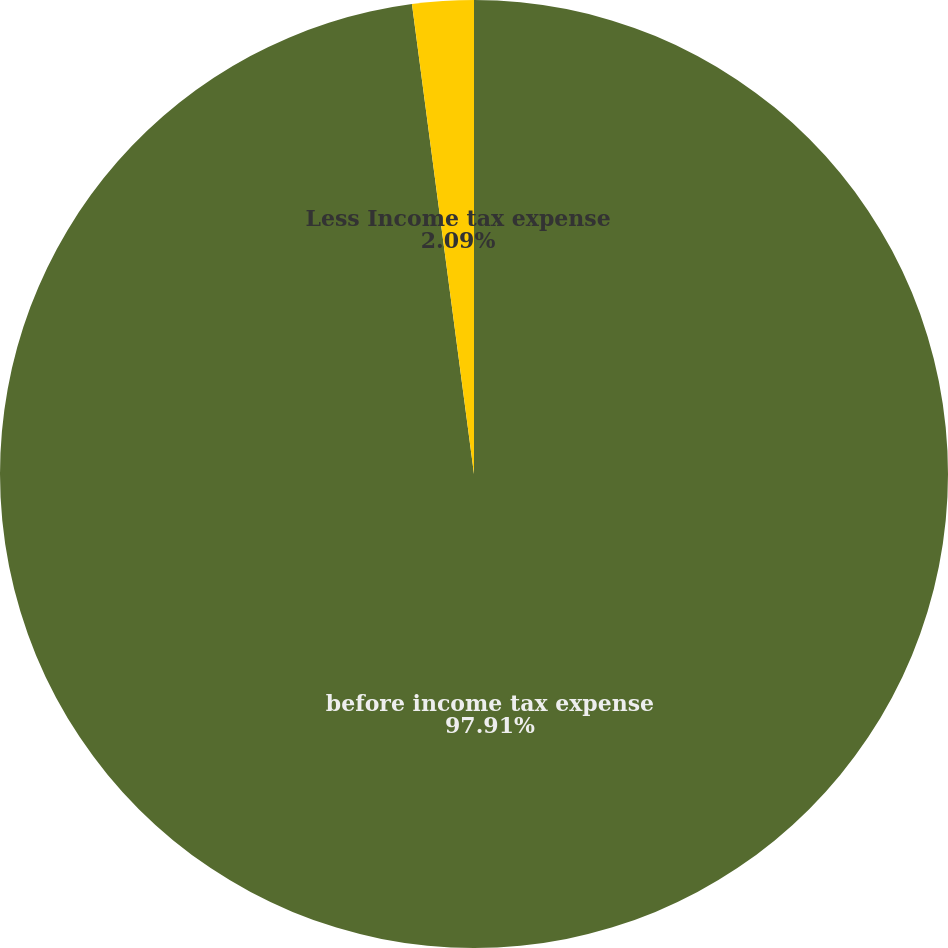Convert chart to OTSL. <chart><loc_0><loc_0><loc_500><loc_500><pie_chart><fcel>before income tax expense<fcel>Less Income tax expense<nl><fcel>97.91%<fcel>2.09%<nl></chart> 